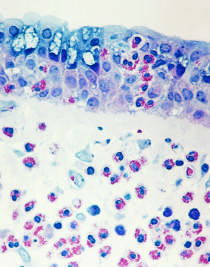s the immediate reaction characterized by an inflammatory infiltrate rich in eosinophils, neutrophils, and t cells?
Answer the question using a single word or phrase. No 